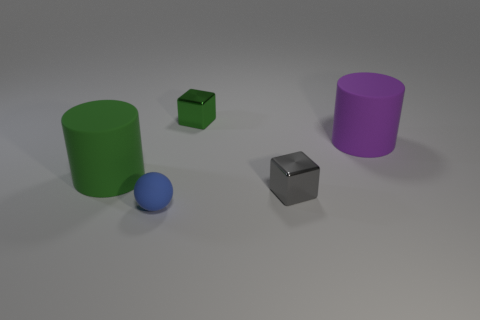Subtract all cylinders. How many objects are left? 3 Subtract 1 balls. How many balls are left? 0 Subtract all blue cylinders. Subtract all blue cubes. How many cylinders are left? 2 Subtract all cyan spheres. How many cyan cubes are left? 0 Subtract all purple cylinders. Subtract all small blocks. How many objects are left? 2 Add 1 tiny shiny blocks. How many tiny shiny blocks are left? 3 Add 3 big purple things. How many big purple things exist? 4 Add 2 blue rubber balls. How many objects exist? 7 Subtract all purple cylinders. How many cylinders are left? 1 Subtract 0 gray spheres. How many objects are left? 5 